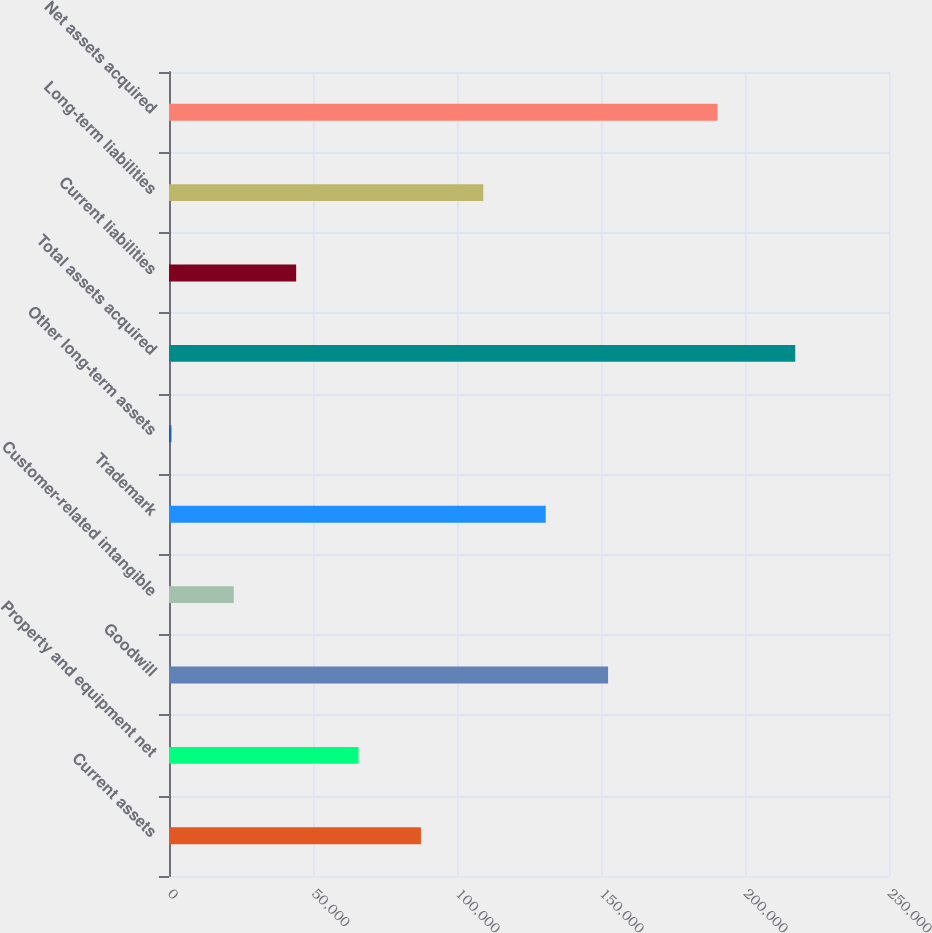Convert chart. <chart><loc_0><loc_0><loc_500><loc_500><bar_chart><fcel>Current assets<fcel>Property and equipment net<fcel>Goodwill<fcel>Customer-related intangible<fcel>Trademark<fcel>Other long-term assets<fcel>Total assets acquired<fcel>Current liabilities<fcel>Long-term liabilities<fcel>Net assets acquired<nl><fcel>87476<fcel>65814<fcel>152462<fcel>22490<fcel>130800<fcel>828<fcel>217448<fcel>44152<fcel>109138<fcel>190465<nl></chart> 